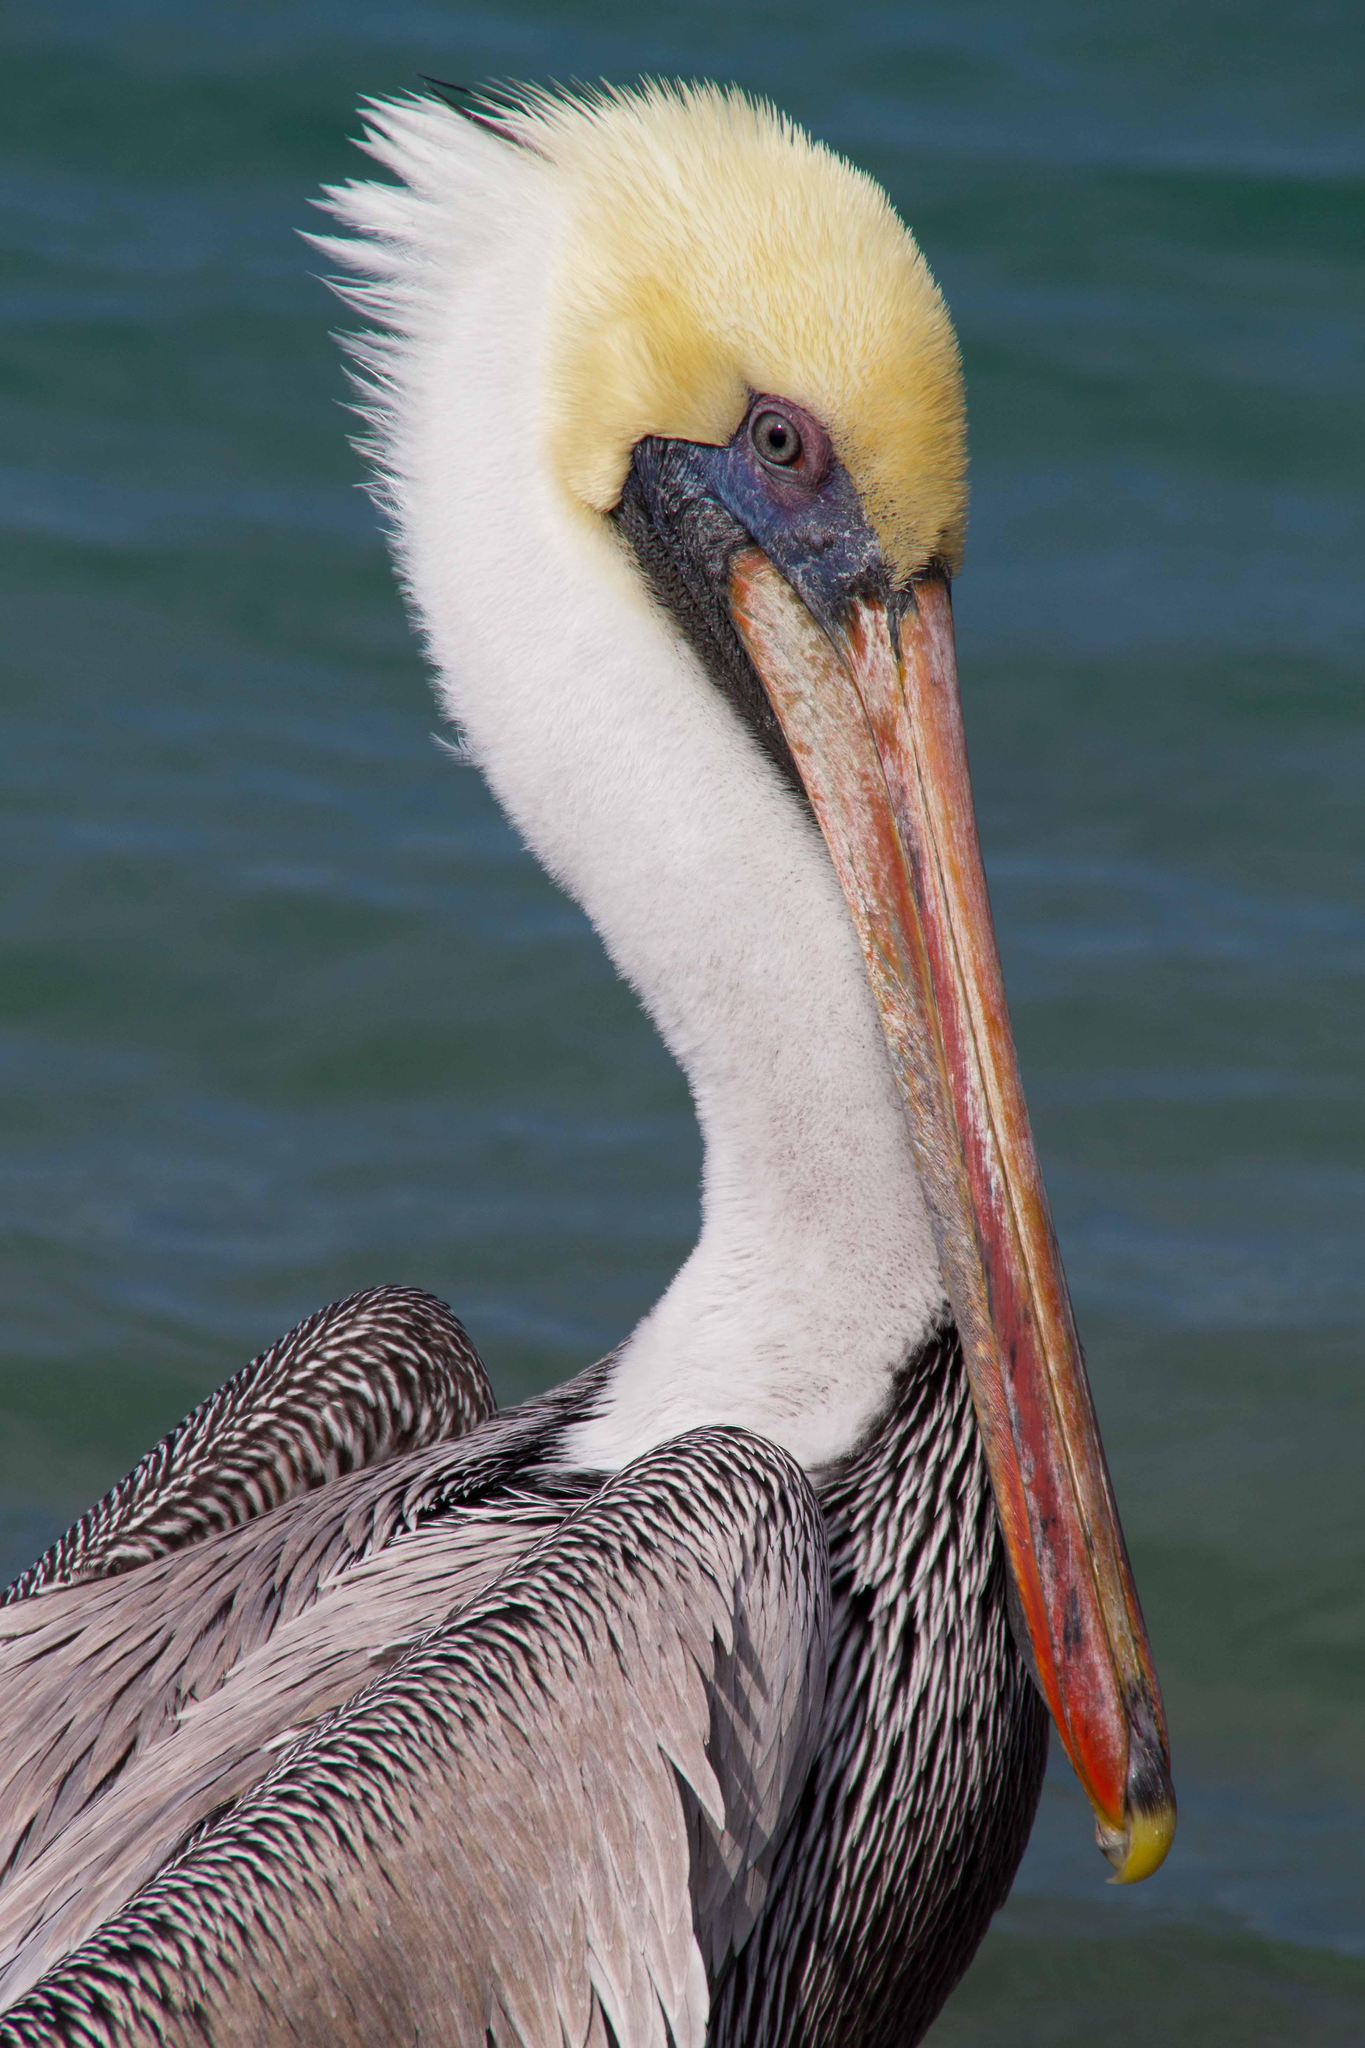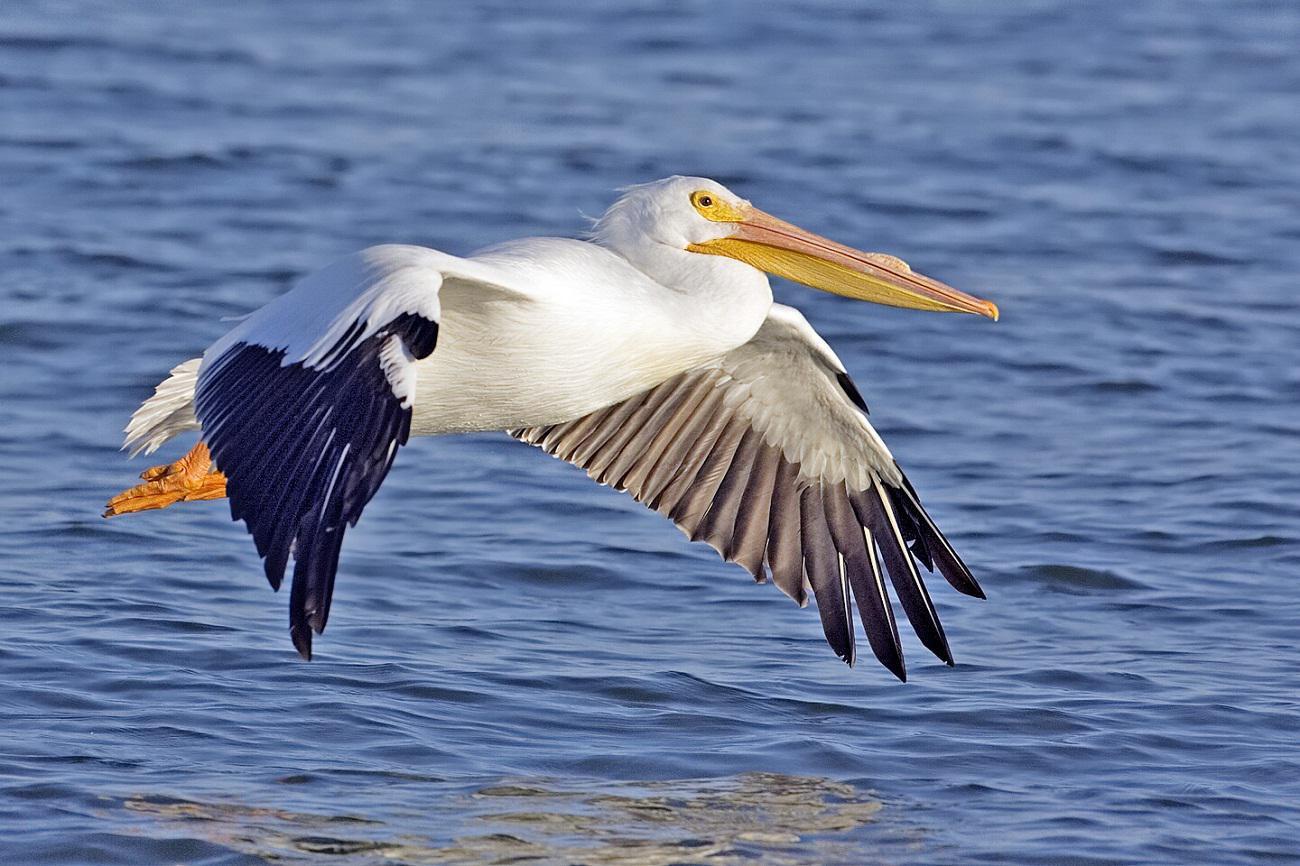The first image is the image on the left, the second image is the image on the right. For the images displayed, is the sentence "The bird in the image on the right is in flight." factually correct? Answer yes or no. Yes. The first image is the image on the left, the second image is the image on the right. Given the left and right images, does the statement "A bird flies right above the water in the image on the right." hold true? Answer yes or no. Yes. The first image is the image on the left, the second image is the image on the right. For the images shown, is this caption "One white-bodied pelican has a closed beak and is in the air above the water with spread wings." true? Answer yes or no. Yes. The first image is the image on the left, the second image is the image on the right. For the images displayed, is the sentence "A fish is visible in the distended lower bill of a floating pelican with its body facing the camera." factually correct? Answer yes or no. No. 